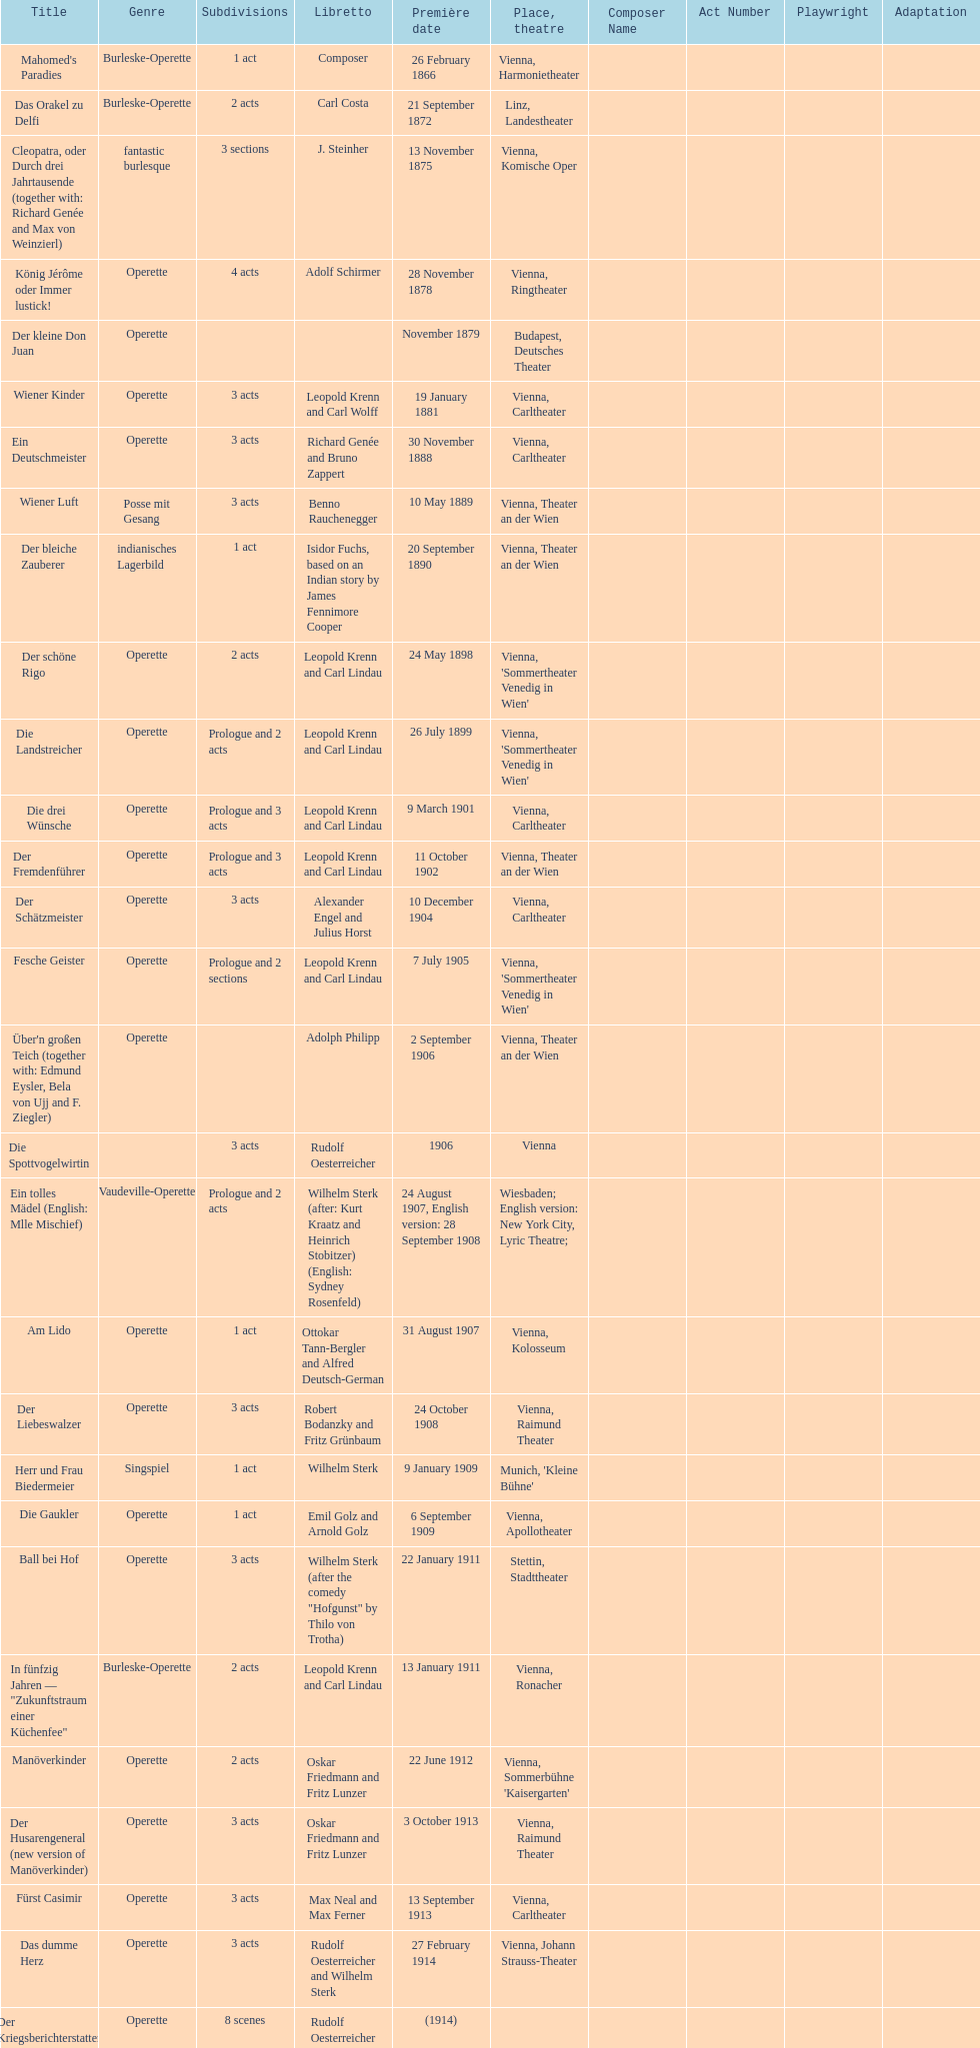Which year did he release his last operetta? 1930. 